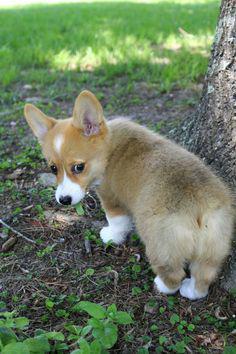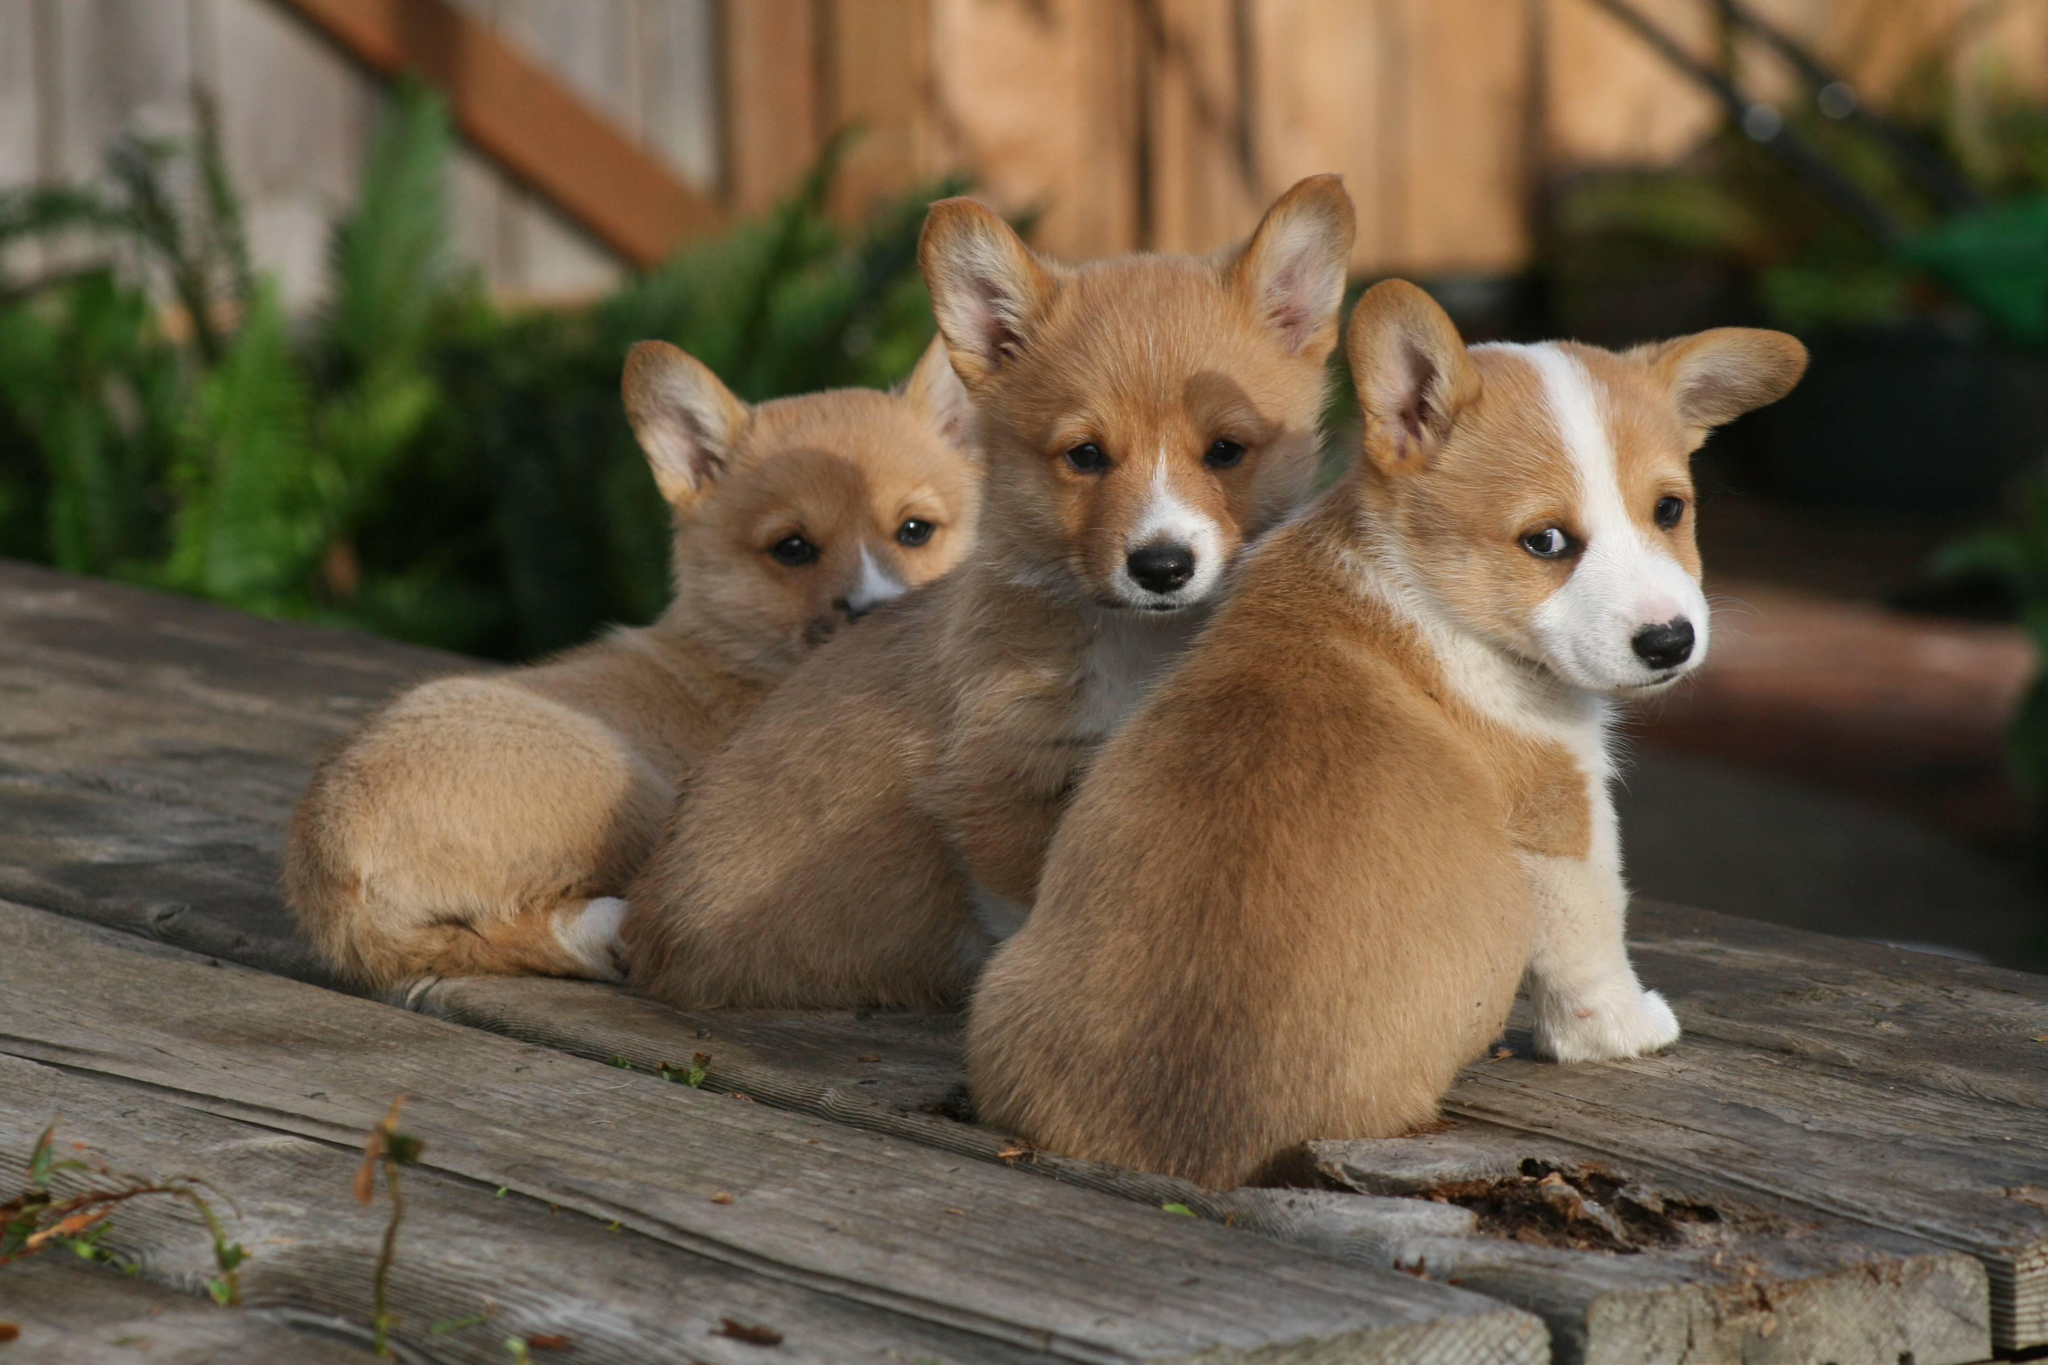The first image is the image on the left, the second image is the image on the right. Considering the images on both sides, is "The left image shows one corgi with its rear to the camera, standing on all fours and looking over one shoulder." valid? Answer yes or no. Yes. The first image is the image on the left, the second image is the image on the right. For the images displayed, is the sentence "One if the images has three dogs looking at the camera." factually correct? Answer yes or no. Yes. 